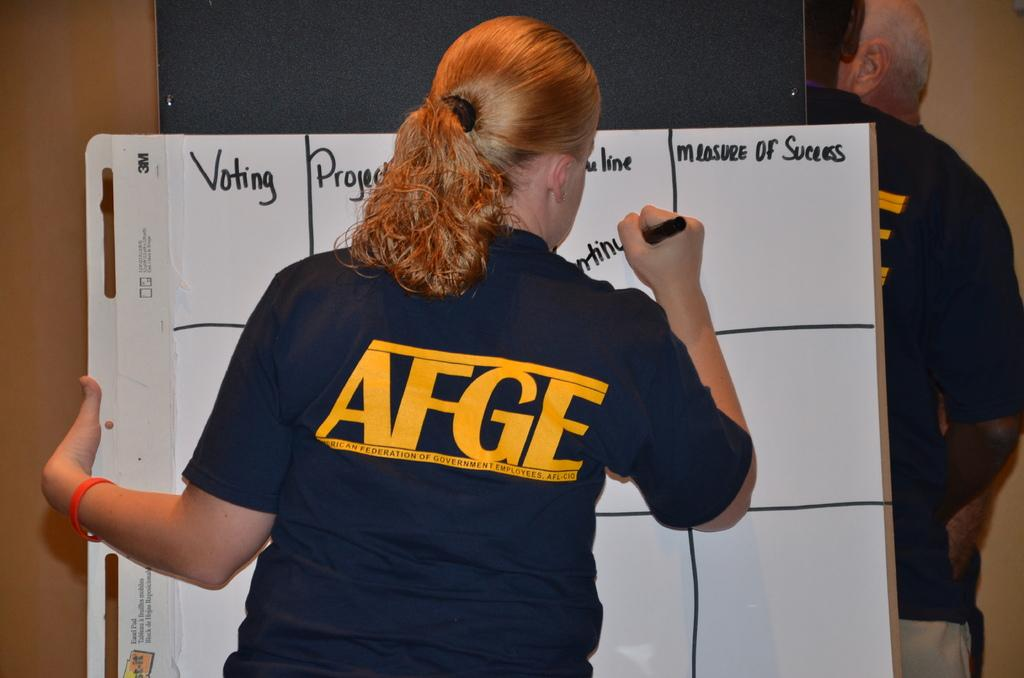What is the person holding in the image? The person is holding a marker in the image. What is the person doing with the marker? The person is writing on a board. Can you describe the people on the right side of the image? There are two persons on the right side of the image. What is located on the right side of the image? There is a wall on the right side of the image. What type of cake is being served to the snake in the image? There is no cake or snake present in the image. What belief system is being discussed by the people in the image? The image does not provide any information about the beliefs or discussions of the people. 